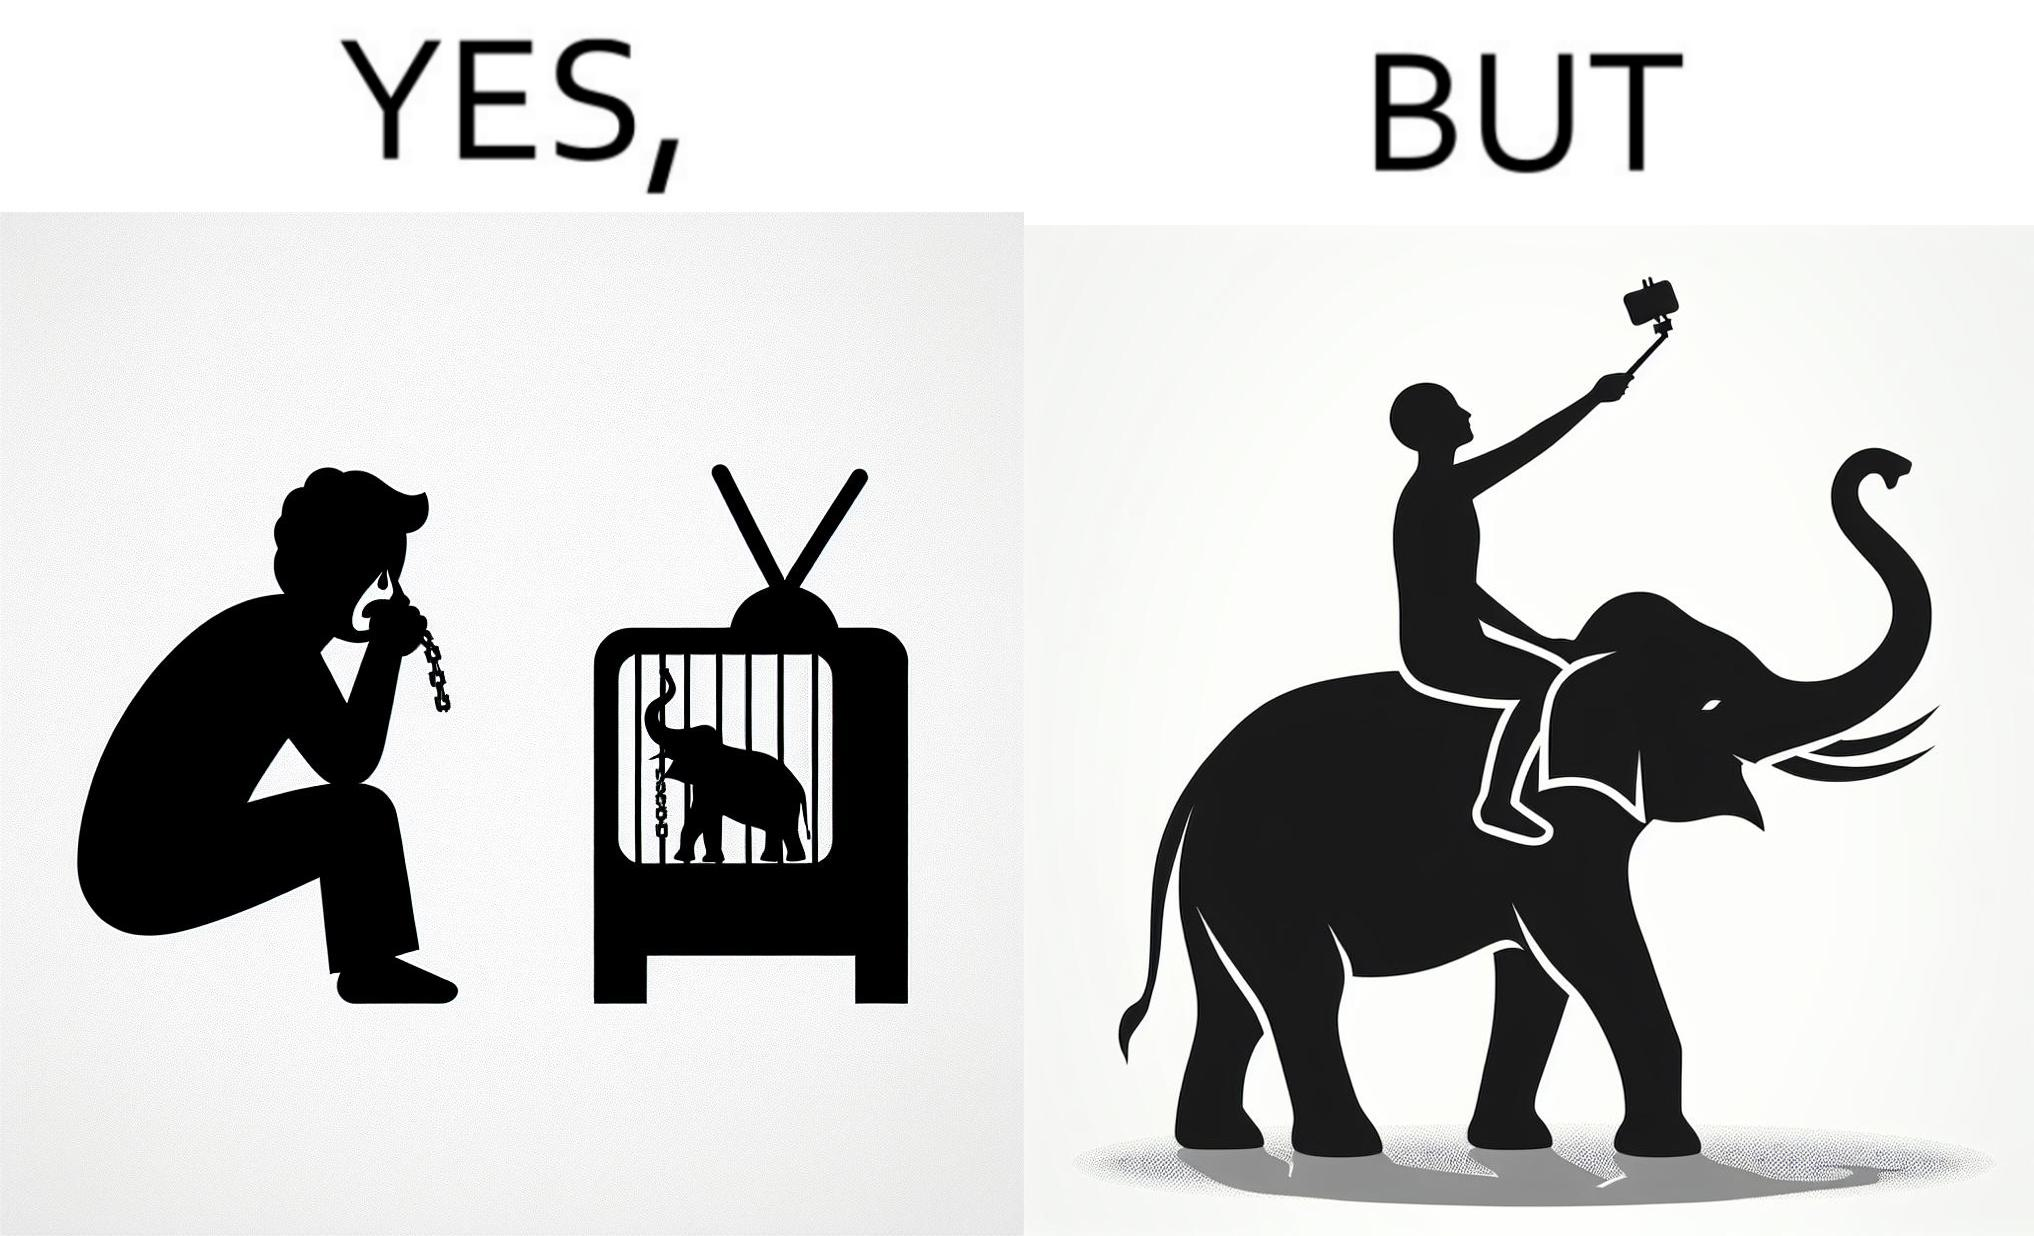What is the satirical meaning behind this image? The image is ironic, because the people who get sentimental over imprisoned animal while watching TV shows often feel okay when using animals for labor 